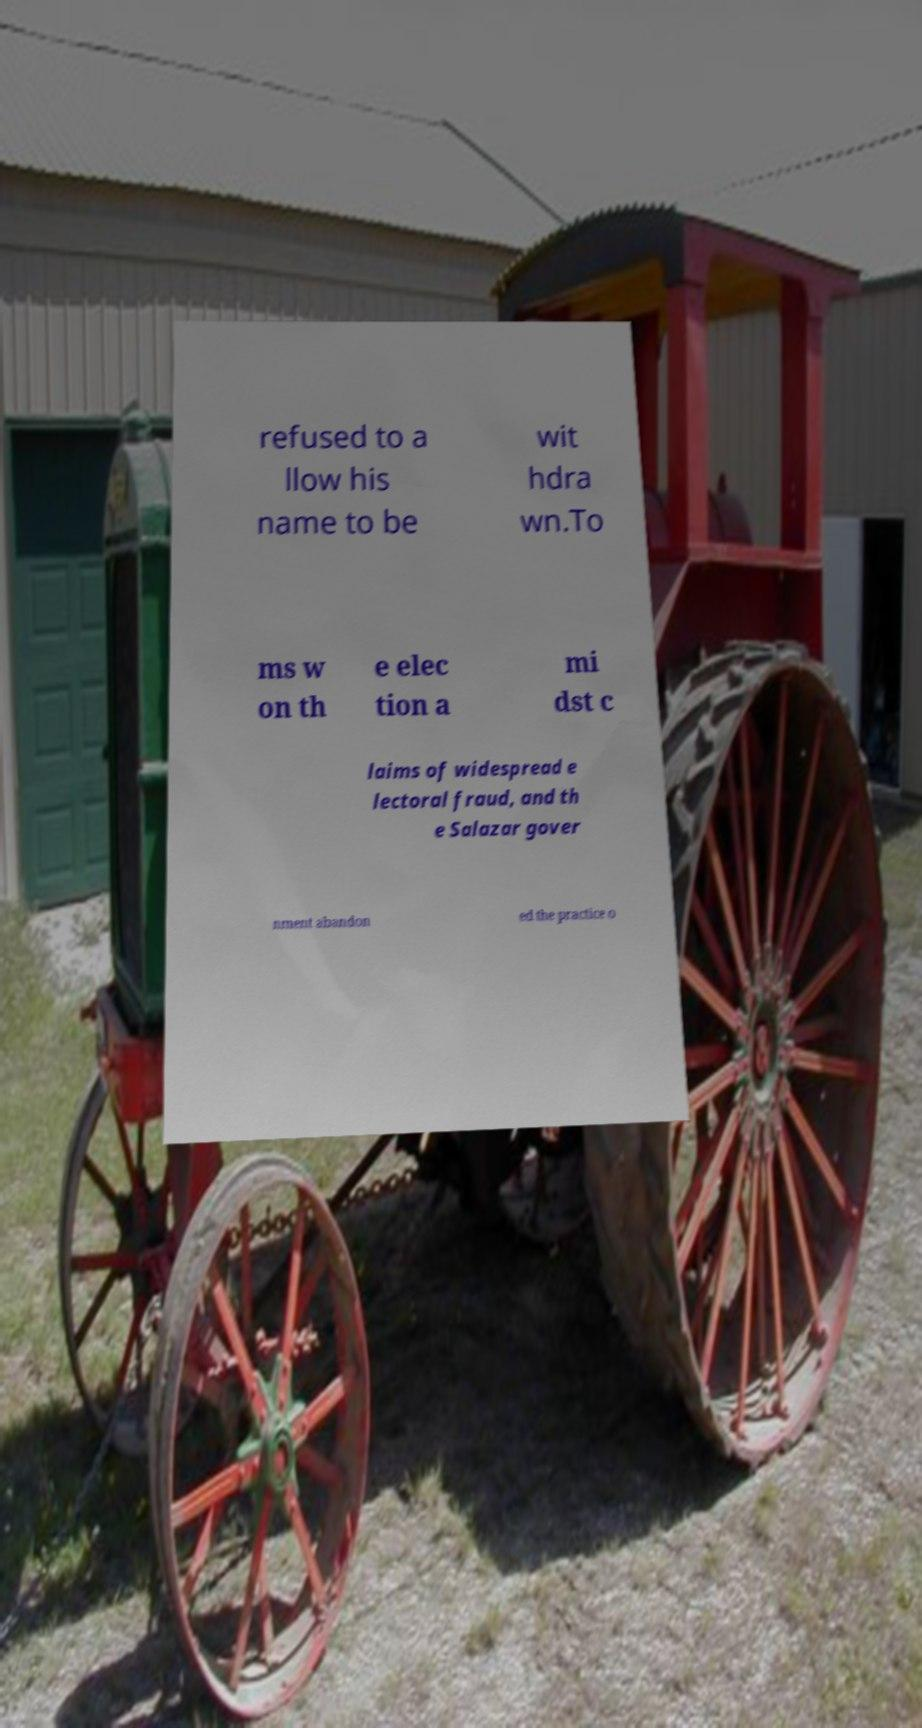What messages or text are displayed in this image? I need them in a readable, typed format. refused to a llow his name to be wit hdra wn.To ms w on th e elec tion a mi dst c laims of widespread e lectoral fraud, and th e Salazar gover nment abandon ed the practice o 